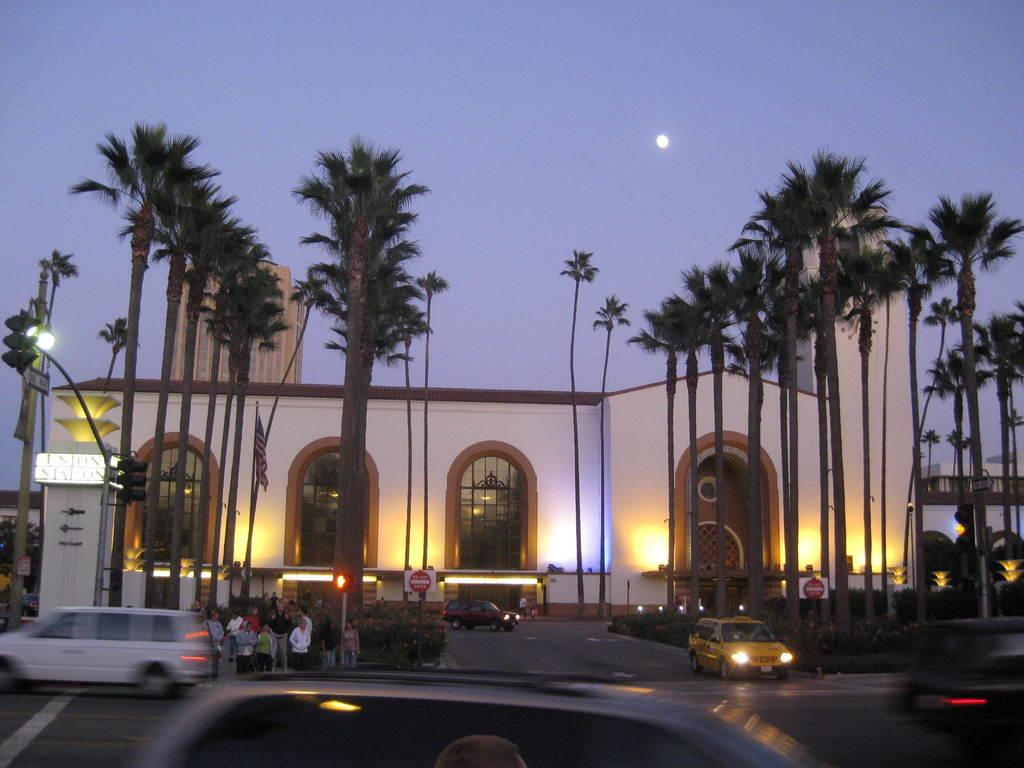What type of structure is visible in the image? There is a building in the image. What type of vegetation can be seen in the image? There are green trees in the image. What is happening on the road in the image? Vehicles are moving on the road in the image. What type of ring is being worn by the tree in the image? There is no ring present in the image, and the tree is not wearing anything. What nation is depicted in the image? The image does not depict a specific nation; it shows a building, trees, and vehicles on a road. 